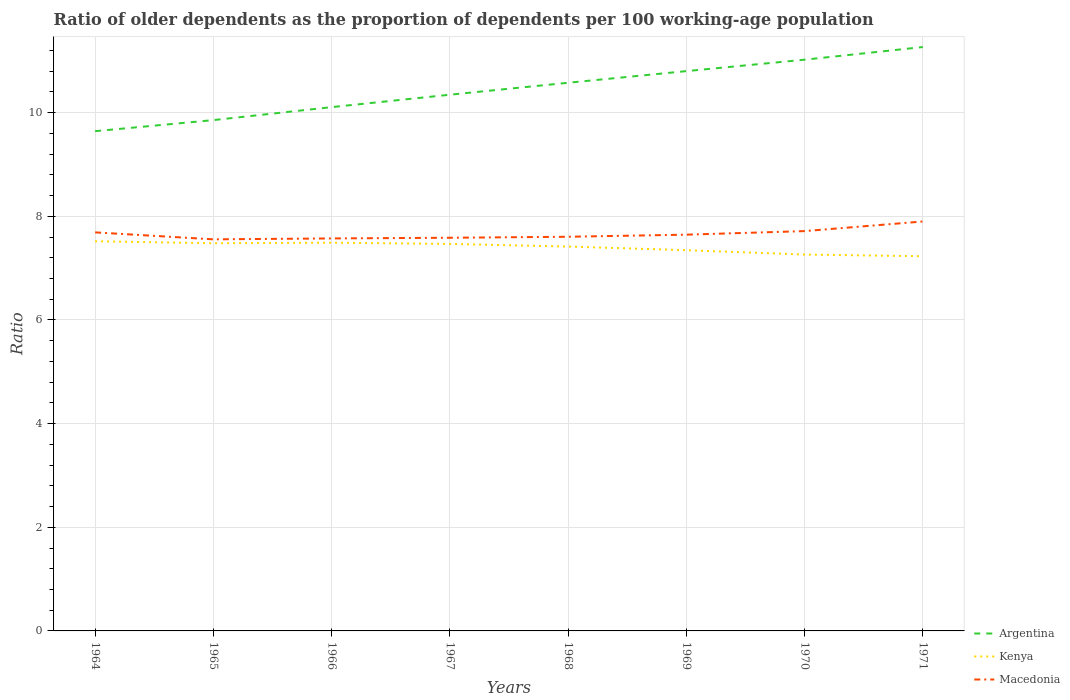How many different coloured lines are there?
Offer a very short reply. 3. Across all years, what is the maximum age dependency ratio(old) in Argentina?
Your response must be concise. 9.64. In which year was the age dependency ratio(old) in Argentina maximum?
Your answer should be very brief. 1964. What is the total age dependency ratio(old) in Argentina in the graph?
Keep it short and to the point. -1.62. What is the difference between the highest and the second highest age dependency ratio(old) in Kenya?
Offer a very short reply. 0.29. What is the difference between the highest and the lowest age dependency ratio(old) in Argentina?
Provide a short and direct response. 4. Is the age dependency ratio(old) in Kenya strictly greater than the age dependency ratio(old) in Argentina over the years?
Offer a very short reply. Yes. How many lines are there?
Keep it short and to the point. 3. What is the difference between two consecutive major ticks on the Y-axis?
Ensure brevity in your answer.  2. Are the values on the major ticks of Y-axis written in scientific E-notation?
Provide a succinct answer. No. Does the graph contain grids?
Provide a succinct answer. Yes. Where does the legend appear in the graph?
Offer a terse response. Bottom right. How are the legend labels stacked?
Ensure brevity in your answer.  Vertical. What is the title of the graph?
Provide a short and direct response. Ratio of older dependents as the proportion of dependents per 100 working-age population. Does "Nicaragua" appear as one of the legend labels in the graph?
Keep it short and to the point. No. What is the label or title of the Y-axis?
Provide a short and direct response. Ratio. What is the Ratio in Argentina in 1964?
Your answer should be very brief. 9.64. What is the Ratio in Kenya in 1964?
Keep it short and to the point. 7.52. What is the Ratio of Macedonia in 1964?
Provide a succinct answer. 7.69. What is the Ratio in Argentina in 1965?
Offer a very short reply. 9.86. What is the Ratio of Kenya in 1965?
Give a very brief answer. 7.48. What is the Ratio of Macedonia in 1965?
Provide a succinct answer. 7.56. What is the Ratio in Argentina in 1966?
Your response must be concise. 10.11. What is the Ratio in Kenya in 1966?
Provide a short and direct response. 7.49. What is the Ratio of Macedonia in 1966?
Offer a terse response. 7.57. What is the Ratio of Argentina in 1967?
Your answer should be compact. 10.35. What is the Ratio of Kenya in 1967?
Offer a very short reply. 7.47. What is the Ratio of Macedonia in 1967?
Make the answer very short. 7.59. What is the Ratio in Argentina in 1968?
Make the answer very short. 10.58. What is the Ratio in Kenya in 1968?
Your answer should be very brief. 7.42. What is the Ratio of Macedonia in 1968?
Offer a very short reply. 7.61. What is the Ratio in Argentina in 1969?
Offer a terse response. 10.8. What is the Ratio in Kenya in 1969?
Offer a very short reply. 7.35. What is the Ratio in Macedonia in 1969?
Make the answer very short. 7.65. What is the Ratio in Argentina in 1970?
Provide a succinct answer. 11.02. What is the Ratio in Kenya in 1970?
Keep it short and to the point. 7.26. What is the Ratio of Macedonia in 1970?
Make the answer very short. 7.71. What is the Ratio of Argentina in 1971?
Your response must be concise. 11.27. What is the Ratio in Kenya in 1971?
Provide a succinct answer. 7.23. What is the Ratio in Macedonia in 1971?
Provide a succinct answer. 7.9. Across all years, what is the maximum Ratio in Argentina?
Make the answer very short. 11.27. Across all years, what is the maximum Ratio in Kenya?
Ensure brevity in your answer.  7.52. Across all years, what is the maximum Ratio in Macedonia?
Your answer should be compact. 7.9. Across all years, what is the minimum Ratio in Argentina?
Provide a short and direct response. 9.64. Across all years, what is the minimum Ratio of Kenya?
Give a very brief answer. 7.23. Across all years, what is the minimum Ratio in Macedonia?
Your answer should be very brief. 7.56. What is the total Ratio of Argentina in the graph?
Provide a succinct answer. 83.62. What is the total Ratio in Kenya in the graph?
Offer a very short reply. 59.21. What is the total Ratio in Macedonia in the graph?
Keep it short and to the point. 61.27. What is the difference between the Ratio in Argentina in 1964 and that in 1965?
Ensure brevity in your answer.  -0.21. What is the difference between the Ratio of Kenya in 1964 and that in 1965?
Provide a short and direct response. 0.04. What is the difference between the Ratio of Macedonia in 1964 and that in 1965?
Your answer should be compact. 0.13. What is the difference between the Ratio of Argentina in 1964 and that in 1966?
Provide a succinct answer. -0.46. What is the difference between the Ratio of Kenya in 1964 and that in 1966?
Give a very brief answer. 0.03. What is the difference between the Ratio in Macedonia in 1964 and that in 1966?
Your answer should be very brief. 0.12. What is the difference between the Ratio in Argentina in 1964 and that in 1967?
Ensure brevity in your answer.  -0.7. What is the difference between the Ratio in Kenya in 1964 and that in 1967?
Your response must be concise. 0.05. What is the difference between the Ratio of Macedonia in 1964 and that in 1967?
Provide a short and direct response. 0.1. What is the difference between the Ratio in Argentina in 1964 and that in 1968?
Offer a terse response. -0.93. What is the difference between the Ratio of Kenya in 1964 and that in 1968?
Give a very brief answer. 0.1. What is the difference between the Ratio of Macedonia in 1964 and that in 1968?
Provide a succinct answer. 0.08. What is the difference between the Ratio in Argentina in 1964 and that in 1969?
Provide a short and direct response. -1.16. What is the difference between the Ratio of Kenya in 1964 and that in 1969?
Ensure brevity in your answer.  0.17. What is the difference between the Ratio in Macedonia in 1964 and that in 1969?
Give a very brief answer. 0.04. What is the difference between the Ratio of Argentina in 1964 and that in 1970?
Ensure brevity in your answer.  -1.38. What is the difference between the Ratio in Kenya in 1964 and that in 1970?
Provide a short and direct response. 0.26. What is the difference between the Ratio in Macedonia in 1964 and that in 1970?
Give a very brief answer. -0.02. What is the difference between the Ratio in Argentina in 1964 and that in 1971?
Offer a very short reply. -1.62. What is the difference between the Ratio of Kenya in 1964 and that in 1971?
Ensure brevity in your answer.  0.29. What is the difference between the Ratio of Macedonia in 1964 and that in 1971?
Keep it short and to the point. -0.21. What is the difference between the Ratio in Argentina in 1965 and that in 1966?
Keep it short and to the point. -0.25. What is the difference between the Ratio of Kenya in 1965 and that in 1966?
Provide a succinct answer. -0.01. What is the difference between the Ratio in Macedonia in 1965 and that in 1966?
Make the answer very short. -0.02. What is the difference between the Ratio of Argentina in 1965 and that in 1967?
Keep it short and to the point. -0.49. What is the difference between the Ratio of Kenya in 1965 and that in 1967?
Your response must be concise. 0.01. What is the difference between the Ratio of Macedonia in 1965 and that in 1967?
Offer a very short reply. -0.03. What is the difference between the Ratio of Argentina in 1965 and that in 1968?
Provide a short and direct response. -0.72. What is the difference between the Ratio of Kenya in 1965 and that in 1968?
Your answer should be very brief. 0.06. What is the difference between the Ratio of Macedonia in 1965 and that in 1968?
Make the answer very short. -0.05. What is the difference between the Ratio of Argentina in 1965 and that in 1969?
Ensure brevity in your answer.  -0.95. What is the difference between the Ratio of Kenya in 1965 and that in 1969?
Your answer should be compact. 0.13. What is the difference between the Ratio of Macedonia in 1965 and that in 1969?
Ensure brevity in your answer.  -0.09. What is the difference between the Ratio in Argentina in 1965 and that in 1970?
Keep it short and to the point. -1.17. What is the difference between the Ratio in Kenya in 1965 and that in 1970?
Offer a very short reply. 0.22. What is the difference between the Ratio of Macedonia in 1965 and that in 1970?
Provide a succinct answer. -0.16. What is the difference between the Ratio in Argentina in 1965 and that in 1971?
Give a very brief answer. -1.41. What is the difference between the Ratio of Kenya in 1965 and that in 1971?
Ensure brevity in your answer.  0.25. What is the difference between the Ratio in Macedonia in 1965 and that in 1971?
Ensure brevity in your answer.  -0.34. What is the difference between the Ratio of Argentina in 1966 and that in 1967?
Keep it short and to the point. -0.24. What is the difference between the Ratio of Kenya in 1966 and that in 1967?
Your response must be concise. 0.02. What is the difference between the Ratio in Macedonia in 1966 and that in 1967?
Your response must be concise. -0.01. What is the difference between the Ratio of Argentina in 1966 and that in 1968?
Offer a very short reply. -0.47. What is the difference between the Ratio of Kenya in 1966 and that in 1968?
Offer a terse response. 0.07. What is the difference between the Ratio in Macedonia in 1966 and that in 1968?
Your answer should be very brief. -0.03. What is the difference between the Ratio of Argentina in 1966 and that in 1969?
Offer a terse response. -0.69. What is the difference between the Ratio of Kenya in 1966 and that in 1969?
Keep it short and to the point. 0.14. What is the difference between the Ratio in Macedonia in 1966 and that in 1969?
Your answer should be compact. -0.07. What is the difference between the Ratio of Argentina in 1966 and that in 1970?
Your answer should be compact. -0.92. What is the difference between the Ratio of Kenya in 1966 and that in 1970?
Provide a short and direct response. 0.23. What is the difference between the Ratio in Macedonia in 1966 and that in 1970?
Offer a very short reply. -0.14. What is the difference between the Ratio in Argentina in 1966 and that in 1971?
Give a very brief answer. -1.16. What is the difference between the Ratio in Kenya in 1966 and that in 1971?
Offer a terse response. 0.26. What is the difference between the Ratio in Macedonia in 1966 and that in 1971?
Make the answer very short. -0.33. What is the difference between the Ratio in Argentina in 1967 and that in 1968?
Keep it short and to the point. -0.23. What is the difference between the Ratio of Kenya in 1967 and that in 1968?
Ensure brevity in your answer.  0.05. What is the difference between the Ratio in Macedonia in 1967 and that in 1968?
Offer a very short reply. -0.02. What is the difference between the Ratio of Argentina in 1967 and that in 1969?
Provide a short and direct response. -0.46. What is the difference between the Ratio of Kenya in 1967 and that in 1969?
Ensure brevity in your answer.  0.12. What is the difference between the Ratio of Macedonia in 1967 and that in 1969?
Your answer should be compact. -0.06. What is the difference between the Ratio in Argentina in 1967 and that in 1970?
Ensure brevity in your answer.  -0.68. What is the difference between the Ratio of Kenya in 1967 and that in 1970?
Provide a succinct answer. 0.21. What is the difference between the Ratio in Macedonia in 1967 and that in 1970?
Your response must be concise. -0.13. What is the difference between the Ratio of Argentina in 1967 and that in 1971?
Provide a short and direct response. -0.92. What is the difference between the Ratio in Kenya in 1967 and that in 1971?
Give a very brief answer. 0.24. What is the difference between the Ratio in Macedonia in 1967 and that in 1971?
Provide a short and direct response. -0.31. What is the difference between the Ratio of Argentina in 1968 and that in 1969?
Offer a terse response. -0.22. What is the difference between the Ratio of Kenya in 1968 and that in 1969?
Ensure brevity in your answer.  0.07. What is the difference between the Ratio in Macedonia in 1968 and that in 1969?
Your response must be concise. -0.04. What is the difference between the Ratio of Argentina in 1968 and that in 1970?
Your response must be concise. -0.45. What is the difference between the Ratio of Kenya in 1968 and that in 1970?
Give a very brief answer. 0.15. What is the difference between the Ratio of Macedonia in 1968 and that in 1970?
Provide a succinct answer. -0.11. What is the difference between the Ratio in Argentina in 1968 and that in 1971?
Provide a short and direct response. -0.69. What is the difference between the Ratio of Kenya in 1968 and that in 1971?
Give a very brief answer. 0.19. What is the difference between the Ratio in Macedonia in 1968 and that in 1971?
Provide a short and direct response. -0.3. What is the difference between the Ratio in Argentina in 1969 and that in 1970?
Offer a terse response. -0.22. What is the difference between the Ratio of Kenya in 1969 and that in 1970?
Your answer should be very brief. 0.08. What is the difference between the Ratio in Macedonia in 1969 and that in 1970?
Provide a short and direct response. -0.07. What is the difference between the Ratio in Argentina in 1969 and that in 1971?
Your answer should be compact. -0.46. What is the difference between the Ratio in Kenya in 1969 and that in 1971?
Provide a short and direct response. 0.12. What is the difference between the Ratio of Macedonia in 1969 and that in 1971?
Your answer should be very brief. -0.25. What is the difference between the Ratio of Argentina in 1970 and that in 1971?
Offer a very short reply. -0.24. What is the difference between the Ratio of Kenya in 1970 and that in 1971?
Keep it short and to the point. 0.03. What is the difference between the Ratio of Macedonia in 1970 and that in 1971?
Keep it short and to the point. -0.19. What is the difference between the Ratio in Argentina in 1964 and the Ratio in Kenya in 1965?
Make the answer very short. 2.16. What is the difference between the Ratio in Argentina in 1964 and the Ratio in Macedonia in 1965?
Make the answer very short. 2.09. What is the difference between the Ratio in Kenya in 1964 and the Ratio in Macedonia in 1965?
Your answer should be very brief. -0.04. What is the difference between the Ratio in Argentina in 1964 and the Ratio in Kenya in 1966?
Offer a terse response. 2.15. What is the difference between the Ratio of Argentina in 1964 and the Ratio of Macedonia in 1966?
Offer a terse response. 2.07. What is the difference between the Ratio in Kenya in 1964 and the Ratio in Macedonia in 1966?
Your response must be concise. -0.05. What is the difference between the Ratio in Argentina in 1964 and the Ratio in Kenya in 1967?
Your answer should be compact. 2.18. What is the difference between the Ratio of Argentina in 1964 and the Ratio of Macedonia in 1967?
Ensure brevity in your answer.  2.06. What is the difference between the Ratio of Kenya in 1964 and the Ratio of Macedonia in 1967?
Provide a succinct answer. -0.07. What is the difference between the Ratio in Argentina in 1964 and the Ratio in Kenya in 1968?
Give a very brief answer. 2.23. What is the difference between the Ratio of Argentina in 1964 and the Ratio of Macedonia in 1968?
Provide a succinct answer. 2.04. What is the difference between the Ratio of Kenya in 1964 and the Ratio of Macedonia in 1968?
Ensure brevity in your answer.  -0.09. What is the difference between the Ratio of Argentina in 1964 and the Ratio of Kenya in 1969?
Keep it short and to the point. 2.3. What is the difference between the Ratio of Argentina in 1964 and the Ratio of Macedonia in 1969?
Give a very brief answer. 2. What is the difference between the Ratio in Kenya in 1964 and the Ratio in Macedonia in 1969?
Make the answer very short. -0.13. What is the difference between the Ratio in Argentina in 1964 and the Ratio in Kenya in 1970?
Your answer should be very brief. 2.38. What is the difference between the Ratio of Argentina in 1964 and the Ratio of Macedonia in 1970?
Keep it short and to the point. 1.93. What is the difference between the Ratio of Kenya in 1964 and the Ratio of Macedonia in 1970?
Offer a very short reply. -0.2. What is the difference between the Ratio in Argentina in 1964 and the Ratio in Kenya in 1971?
Your answer should be compact. 2.41. What is the difference between the Ratio of Argentina in 1964 and the Ratio of Macedonia in 1971?
Provide a short and direct response. 1.74. What is the difference between the Ratio in Kenya in 1964 and the Ratio in Macedonia in 1971?
Make the answer very short. -0.38. What is the difference between the Ratio of Argentina in 1965 and the Ratio of Kenya in 1966?
Offer a terse response. 2.37. What is the difference between the Ratio in Argentina in 1965 and the Ratio in Macedonia in 1966?
Provide a short and direct response. 2.28. What is the difference between the Ratio in Kenya in 1965 and the Ratio in Macedonia in 1966?
Ensure brevity in your answer.  -0.09. What is the difference between the Ratio of Argentina in 1965 and the Ratio of Kenya in 1967?
Keep it short and to the point. 2.39. What is the difference between the Ratio in Argentina in 1965 and the Ratio in Macedonia in 1967?
Your response must be concise. 2.27. What is the difference between the Ratio in Kenya in 1965 and the Ratio in Macedonia in 1967?
Offer a very short reply. -0.11. What is the difference between the Ratio in Argentina in 1965 and the Ratio in Kenya in 1968?
Provide a short and direct response. 2.44. What is the difference between the Ratio in Argentina in 1965 and the Ratio in Macedonia in 1968?
Offer a very short reply. 2.25. What is the difference between the Ratio in Kenya in 1965 and the Ratio in Macedonia in 1968?
Your answer should be compact. -0.12. What is the difference between the Ratio in Argentina in 1965 and the Ratio in Kenya in 1969?
Provide a short and direct response. 2.51. What is the difference between the Ratio in Argentina in 1965 and the Ratio in Macedonia in 1969?
Keep it short and to the point. 2.21. What is the difference between the Ratio of Kenya in 1965 and the Ratio of Macedonia in 1969?
Your answer should be very brief. -0.17. What is the difference between the Ratio of Argentina in 1965 and the Ratio of Kenya in 1970?
Provide a short and direct response. 2.59. What is the difference between the Ratio in Argentina in 1965 and the Ratio in Macedonia in 1970?
Give a very brief answer. 2.14. What is the difference between the Ratio in Kenya in 1965 and the Ratio in Macedonia in 1970?
Provide a succinct answer. -0.23. What is the difference between the Ratio in Argentina in 1965 and the Ratio in Kenya in 1971?
Provide a short and direct response. 2.63. What is the difference between the Ratio of Argentina in 1965 and the Ratio of Macedonia in 1971?
Provide a short and direct response. 1.96. What is the difference between the Ratio of Kenya in 1965 and the Ratio of Macedonia in 1971?
Your answer should be very brief. -0.42. What is the difference between the Ratio of Argentina in 1966 and the Ratio of Kenya in 1967?
Provide a short and direct response. 2.64. What is the difference between the Ratio of Argentina in 1966 and the Ratio of Macedonia in 1967?
Your answer should be very brief. 2.52. What is the difference between the Ratio of Kenya in 1966 and the Ratio of Macedonia in 1967?
Ensure brevity in your answer.  -0.1. What is the difference between the Ratio in Argentina in 1966 and the Ratio in Kenya in 1968?
Provide a succinct answer. 2.69. What is the difference between the Ratio in Argentina in 1966 and the Ratio in Macedonia in 1968?
Offer a very short reply. 2.5. What is the difference between the Ratio in Kenya in 1966 and the Ratio in Macedonia in 1968?
Offer a terse response. -0.11. What is the difference between the Ratio in Argentina in 1966 and the Ratio in Kenya in 1969?
Give a very brief answer. 2.76. What is the difference between the Ratio of Argentina in 1966 and the Ratio of Macedonia in 1969?
Offer a very short reply. 2.46. What is the difference between the Ratio of Kenya in 1966 and the Ratio of Macedonia in 1969?
Provide a succinct answer. -0.15. What is the difference between the Ratio in Argentina in 1966 and the Ratio in Kenya in 1970?
Provide a succinct answer. 2.84. What is the difference between the Ratio in Argentina in 1966 and the Ratio in Macedonia in 1970?
Your answer should be very brief. 2.39. What is the difference between the Ratio in Kenya in 1966 and the Ratio in Macedonia in 1970?
Make the answer very short. -0.22. What is the difference between the Ratio of Argentina in 1966 and the Ratio of Kenya in 1971?
Your answer should be very brief. 2.88. What is the difference between the Ratio in Argentina in 1966 and the Ratio in Macedonia in 1971?
Offer a terse response. 2.21. What is the difference between the Ratio of Kenya in 1966 and the Ratio of Macedonia in 1971?
Provide a succinct answer. -0.41. What is the difference between the Ratio in Argentina in 1967 and the Ratio in Kenya in 1968?
Provide a succinct answer. 2.93. What is the difference between the Ratio of Argentina in 1967 and the Ratio of Macedonia in 1968?
Ensure brevity in your answer.  2.74. What is the difference between the Ratio of Kenya in 1967 and the Ratio of Macedonia in 1968?
Ensure brevity in your answer.  -0.14. What is the difference between the Ratio in Argentina in 1967 and the Ratio in Kenya in 1969?
Provide a short and direct response. 3. What is the difference between the Ratio in Argentina in 1967 and the Ratio in Macedonia in 1969?
Ensure brevity in your answer.  2.7. What is the difference between the Ratio of Kenya in 1967 and the Ratio of Macedonia in 1969?
Ensure brevity in your answer.  -0.18. What is the difference between the Ratio of Argentina in 1967 and the Ratio of Kenya in 1970?
Give a very brief answer. 3.08. What is the difference between the Ratio in Argentina in 1967 and the Ratio in Macedonia in 1970?
Provide a short and direct response. 2.63. What is the difference between the Ratio in Kenya in 1967 and the Ratio in Macedonia in 1970?
Your answer should be very brief. -0.25. What is the difference between the Ratio in Argentina in 1967 and the Ratio in Kenya in 1971?
Provide a succinct answer. 3.12. What is the difference between the Ratio of Argentina in 1967 and the Ratio of Macedonia in 1971?
Your response must be concise. 2.45. What is the difference between the Ratio in Kenya in 1967 and the Ratio in Macedonia in 1971?
Give a very brief answer. -0.43. What is the difference between the Ratio in Argentina in 1968 and the Ratio in Kenya in 1969?
Your response must be concise. 3.23. What is the difference between the Ratio of Argentina in 1968 and the Ratio of Macedonia in 1969?
Provide a short and direct response. 2.93. What is the difference between the Ratio in Kenya in 1968 and the Ratio in Macedonia in 1969?
Offer a very short reply. -0.23. What is the difference between the Ratio of Argentina in 1968 and the Ratio of Kenya in 1970?
Make the answer very short. 3.32. What is the difference between the Ratio in Argentina in 1968 and the Ratio in Macedonia in 1970?
Your response must be concise. 2.86. What is the difference between the Ratio in Kenya in 1968 and the Ratio in Macedonia in 1970?
Make the answer very short. -0.3. What is the difference between the Ratio in Argentina in 1968 and the Ratio in Kenya in 1971?
Offer a terse response. 3.35. What is the difference between the Ratio of Argentina in 1968 and the Ratio of Macedonia in 1971?
Ensure brevity in your answer.  2.68. What is the difference between the Ratio in Kenya in 1968 and the Ratio in Macedonia in 1971?
Your response must be concise. -0.48. What is the difference between the Ratio in Argentina in 1969 and the Ratio in Kenya in 1970?
Keep it short and to the point. 3.54. What is the difference between the Ratio of Argentina in 1969 and the Ratio of Macedonia in 1970?
Your response must be concise. 3.09. What is the difference between the Ratio of Kenya in 1969 and the Ratio of Macedonia in 1970?
Give a very brief answer. -0.37. What is the difference between the Ratio in Argentina in 1969 and the Ratio in Kenya in 1971?
Provide a succinct answer. 3.57. What is the difference between the Ratio in Argentina in 1969 and the Ratio in Macedonia in 1971?
Your answer should be very brief. 2.9. What is the difference between the Ratio in Kenya in 1969 and the Ratio in Macedonia in 1971?
Make the answer very short. -0.55. What is the difference between the Ratio in Argentina in 1970 and the Ratio in Kenya in 1971?
Give a very brief answer. 3.79. What is the difference between the Ratio of Argentina in 1970 and the Ratio of Macedonia in 1971?
Make the answer very short. 3.12. What is the difference between the Ratio in Kenya in 1970 and the Ratio in Macedonia in 1971?
Give a very brief answer. -0.64. What is the average Ratio of Argentina per year?
Provide a short and direct response. 10.45. What is the average Ratio in Kenya per year?
Your answer should be very brief. 7.4. What is the average Ratio of Macedonia per year?
Give a very brief answer. 7.66. In the year 1964, what is the difference between the Ratio of Argentina and Ratio of Kenya?
Give a very brief answer. 2.12. In the year 1964, what is the difference between the Ratio of Argentina and Ratio of Macedonia?
Keep it short and to the point. 1.95. In the year 1964, what is the difference between the Ratio of Kenya and Ratio of Macedonia?
Your answer should be very brief. -0.17. In the year 1965, what is the difference between the Ratio in Argentina and Ratio in Kenya?
Offer a very short reply. 2.38. In the year 1965, what is the difference between the Ratio in Argentina and Ratio in Macedonia?
Ensure brevity in your answer.  2.3. In the year 1965, what is the difference between the Ratio of Kenya and Ratio of Macedonia?
Provide a short and direct response. -0.08. In the year 1966, what is the difference between the Ratio in Argentina and Ratio in Kenya?
Provide a short and direct response. 2.62. In the year 1966, what is the difference between the Ratio of Argentina and Ratio of Macedonia?
Your answer should be compact. 2.53. In the year 1966, what is the difference between the Ratio in Kenya and Ratio in Macedonia?
Your response must be concise. -0.08. In the year 1967, what is the difference between the Ratio in Argentina and Ratio in Kenya?
Provide a succinct answer. 2.88. In the year 1967, what is the difference between the Ratio of Argentina and Ratio of Macedonia?
Provide a short and direct response. 2.76. In the year 1967, what is the difference between the Ratio in Kenya and Ratio in Macedonia?
Your answer should be compact. -0.12. In the year 1968, what is the difference between the Ratio of Argentina and Ratio of Kenya?
Provide a short and direct response. 3.16. In the year 1968, what is the difference between the Ratio of Argentina and Ratio of Macedonia?
Keep it short and to the point. 2.97. In the year 1968, what is the difference between the Ratio in Kenya and Ratio in Macedonia?
Ensure brevity in your answer.  -0.19. In the year 1969, what is the difference between the Ratio of Argentina and Ratio of Kenya?
Offer a terse response. 3.46. In the year 1969, what is the difference between the Ratio in Argentina and Ratio in Macedonia?
Provide a short and direct response. 3.16. In the year 1969, what is the difference between the Ratio of Kenya and Ratio of Macedonia?
Ensure brevity in your answer.  -0.3. In the year 1970, what is the difference between the Ratio of Argentina and Ratio of Kenya?
Ensure brevity in your answer.  3.76. In the year 1970, what is the difference between the Ratio of Argentina and Ratio of Macedonia?
Give a very brief answer. 3.31. In the year 1970, what is the difference between the Ratio of Kenya and Ratio of Macedonia?
Your response must be concise. -0.45. In the year 1971, what is the difference between the Ratio of Argentina and Ratio of Kenya?
Offer a terse response. 4.04. In the year 1971, what is the difference between the Ratio in Argentina and Ratio in Macedonia?
Offer a terse response. 3.37. In the year 1971, what is the difference between the Ratio in Kenya and Ratio in Macedonia?
Give a very brief answer. -0.67. What is the ratio of the Ratio of Argentina in 1964 to that in 1965?
Offer a very short reply. 0.98. What is the ratio of the Ratio of Macedonia in 1964 to that in 1965?
Make the answer very short. 1.02. What is the ratio of the Ratio of Argentina in 1964 to that in 1966?
Give a very brief answer. 0.95. What is the ratio of the Ratio in Kenya in 1964 to that in 1966?
Ensure brevity in your answer.  1. What is the ratio of the Ratio of Macedonia in 1964 to that in 1966?
Offer a terse response. 1.02. What is the ratio of the Ratio in Argentina in 1964 to that in 1967?
Make the answer very short. 0.93. What is the ratio of the Ratio in Kenya in 1964 to that in 1967?
Offer a very short reply. 1.01. What is the ratio of the Ratio in Macedonia in 1964 to that in 1967?
Provide a short and direct response. 1.01. What is the ratio of the Ratio in Argentina in 1964 to that in 1968?
Your response must be concise. 0.91. What is the ratio of the Ratio of Kenya in 1964 to that in 1968?
Make the answer very short. 1.01. What is the ratio of the Ratio in Macedonia in 1964 to that in 1968?
Your answer should be very brief. 1.01. What is the ratio of the Ratio of Argentina in 1964 to that in 1969?
Make the answer very short. 0.89. What is the ratio of the Ratio in Kenya in 1964 to that in 1969?
Your answer should be very brief. 1.02. What is the ratio of the Ratio of Argentina in 1964 to that in 1970?
Make the answer very short. 0.87. What is the ratio of the Ratio in Kenya in 1964 to that in 1970?
Give a very brief answer. 1.04. What is the ratio of the Ratio in Argentina in 1964 to that in 1971?
Offer a very short reply. 0.86. What is the ratio of the Ratio in Kenya in 1964 to that in 1971?
Make the answer very short. 1.04. What is the ratio of the Ratio in Macedonia in 1964 to that in 1971?
Provide a short and direct response. 0.97. What is the ratio of the Ratio in Argentina in 1965 to that in 1966?
Make the answer very short. 0.98. What is the ratio of the Ratio of Kenya in 1965 to that in 1966?
Your response must be concise. 1. What is the ratio of the Ratio of Macedonia in 1965 to that in 1966?
Provide a short and direct response. 1. What is the ratio of the Ratio in Argentina in 1965 to that in 1967?
Your answer should be very brief. 0.95. What is the ratio of the Ratio of Kenya in 1965 to that in 1967?
Your response must be concise. 1. What is the ratio of the Ratio of Macedonia in 1965 to that in 1967?
Give a very brief answer. 1. What is the ratio of the Ratio in Argentina in 1965 to that in 1968?
Offer a terse response. 0.93. What is the ratio of the Ratio of Kenya in 1965 to that in 1968?
Ensure brevity in your answer.  1.01. What is the ratio of the Ratio of Argentina in 1965 to that in 1969?
Make the answer very short. 0.91. What is the ratio of the Ratio in Kenya in 1965 to that in 1969?
Provide a short and direct response. 1.02. What is the ratio of the Ratio of Argentina in 1965 to that in 1970?
Give a very brief answer. 0.89. What is the ratio of the Ratio in Kenya in 1965 to that in 1970?
Offer a terse response. 1.03. What is the ratio of the Ratio in Macedonia in 1965 to that in 1970?
Give a very brief answer. 0.98. What is the ratio of the Ratio in Argentina in 1965 to that in 1971?
Give a very brief answer. 0.87. What is the ratio of the Ratio in Kenya in 1965 to that in 1971?
Give a very brief answer. 1.03. What is the ratio of the Ratio in Macedonia in 1965 to that in 1971?
Your answer should be very brief. 0.96. What is the ratio of the Ratio of Argentina in 1966 to that in 1967?
Provide a short and direct response. 0.98. What is the ratio of the Ratio in Kenya in 1966 to that in 1967?
Make the answer very short. 1. What is the ratio of the Ratio in Macedonia in 1966 to that in 1967?
Make the answer very short. 1. What is the ratio of the Ratio of Argentina in 1966 to that in 1968?
Provide a succinct answer. 0.96. What is the ratio of the Ratio of Kenya in 1966 to that in 1968?
Your answer should be compact. 1.01. What is the ratio of the Ratio in Macedonia in 1966 to that in 1968?
Provide a short and direct response. 1. What is the ratio of the Ratio of Argentina in 1966 to that in 1969?
Offer a terse response. 0.94. What is the ratio of the Ratio of Kenya in 1966 to that in 1969?
Your answer should be compact. 1.02. What is the ratio of the Ratio in Argentina in 1966 to that in 1970?
Offer a terse response. 0.92. What is the ratio of the Ratio in Kenya in 1966 to that in 1970?
Provide a succinct answer. 1.03. What is the ratio of the Ratio in Macedonia in 1966 to that in 1970?
Your response must be concise. 0.98. What is the ratio of the Ratio of Argentina in 1966 to that in 1971?
Offer a very short reply. 0.9. What is the ratio of the Ratio of Kenya in 1966 to that in 1971?
Your response must be concise. 1.04. What is the ratio of the Ratio in Macedonia in 1966 to that in 1971?
Provide a short and direct response. 0.96. What is the ratio of the Ratio of Argentina in 1967 to that in 1968?
Offer a terse response. 0.98. What is the ratio of the Ratio of Kenya in 1967 to that in 1968?
Ensure brevity in your answer.  1.01. What is the ratio of the Ratio in Macedonia in 1967 to that in 1968?
Provide a succinct answer. 1. What is the ratio of the Ratio in Argentina in 1967 to that in 1969?
Make the answer very short. 0.96. What is the ratio of the Ratio of Kenya in 1967 to that in 1969?
Ensure brevity in your answer.  1.02. What is the ratio of the Ratio of Argentina in 1967 to that in 1970?
Offer a very short reply. 0.94. What is the ratio of the Ratio of Kenya in 1967 to that in 1970?
Give a very brief answer. 1.03. What is the ratio of the Ratio in Macedonia in 1967 to that in 1970?
Your response must be concise. 0.98. What is the ratio of the Ratio in Argentina in 1967 to that in 1971?
Give a very brief answer. 0.92. What is the ratio of the Ratio of Kenya in 1967 to that in 1971?
Provide a succinct answer. 1.03. What is the ratio of the Ratio of Macedonia in 1967 to that in 1971?
Make the answer very short. 0.96. What is the ratio of the Ratio of Argentina in 1968 to that in 1969?
Give a very brief answer. 0.98. What is the ratio of the Ratio of Kenya in 1968 to that in 1969?
Your answer should be compact. 1.01. What is the ratio of the Ratio in Argentina in 1968 to that in 1970?
Give a very brief answer. 0.96. What is the ratio of the Ratio of Kenya in 1968 to that in 1970?
Ensure brevity in your answer.  1.02. What is the ratio of the Ratio of Macedonia in 1968 to that in 1970?
Provide a short and direct response. 0.99. What is the ratio of the Ratio in Argentina in 1968 to that in 1971?
Give a very brief answer. 0.94. What is the ratio of the Ratio of Kenya in 1968 to that in 1971?
Your answer should be very brief. 1.03. What is the ratio of the Ratio in Macedonia in 1968 to that in 1971?
Make the answer very short. 0.96. What is the ratio of the Ratio in Argentina in 1969 to that in 1970?
Give a very brief answer. 0.98. What is the ratio of the Ratio of Kenya in 1969 to that in 1970?
Keep it short and to the point. 1.01. What is the ratio of the Ratio of Macedonia in 1969 to that in 1970?
Provide a short and direct response. 0.99. What is the ratio of the Ratio of Argentina in 1969 to that in 1971?
Your answer should be compact. 0.96. What is the ratio of the Ratio of Kenya in 1969 to that in 1971?
Provide a short and direct response. 1.02. What is the ratio of the Ratio in Macedonia in 1969 to that in 1971?
Ensure brevity in your answer.  0.97. What is the ratio of the Ratio in Argentina in 1970 to that in 1971?
Provide a succinct answer. 0.98. What is the ratio of the Ratio of Macedonia in 1970 to that in 1971?
Your answer should be compact. 0.98. What is the difference between the highest and the second highest Ratio of Argentina?
Provide a short and direct response. 0.24. What is the difference between the highest and the second highest Ratio in Kenya?
Your answer should be compact. 0.03. What is the difference between the highest and the second highest Ratio in Macedonia?
Offer a very short reply. 0.19. What is the difference between the highest and the lowest Ratio in Argentina?
Keep it short and to the point. 1.62. What is the difference between the highest and the lowest Ratio in Kenya?
Your response must be concise. 0.29. What is the difference between the highest and the lowest Ratio in Macedonia?
Ensure brevity in your answer.  0.34. 